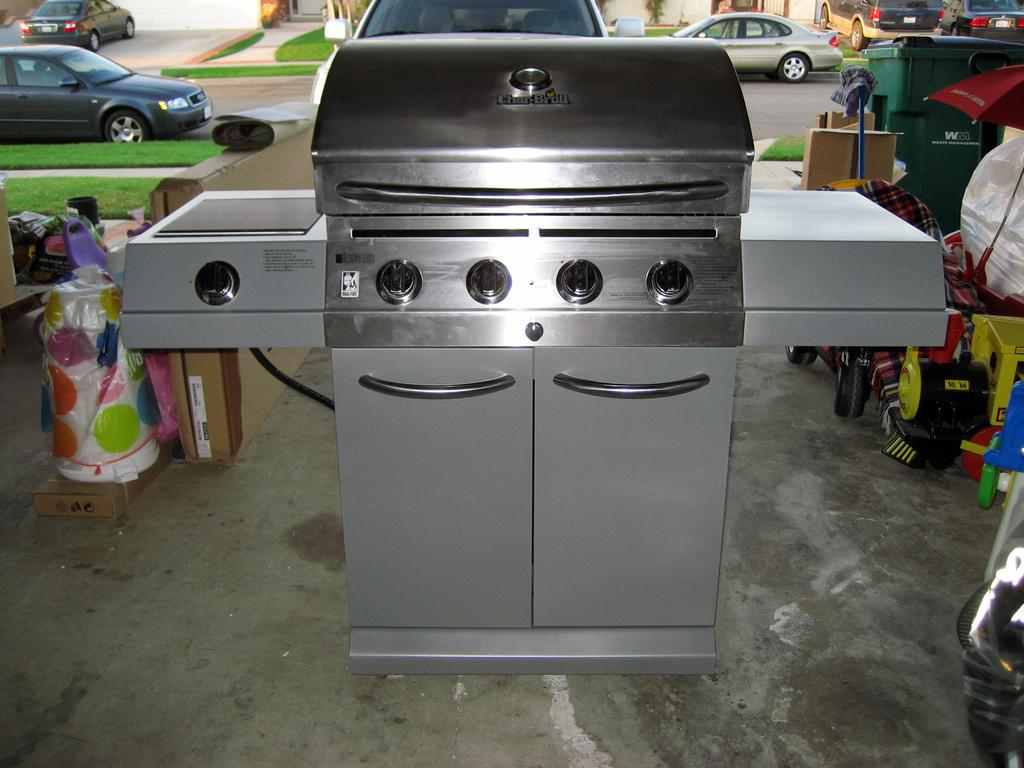What type of appliance can be seen in the image? There is a stove in the image. What type of storage furniture is present in the image? There are cupboards in the image. What is located in the background of the image? In the background of the image, there is a bin, an umbrella, vehicles, grass, and other unspecified things. What type of horse is visible in the image? There is no horse present in the image. What type of jar is being used to store the partner's belongings in the image? There is no partner or jar present in the image. 